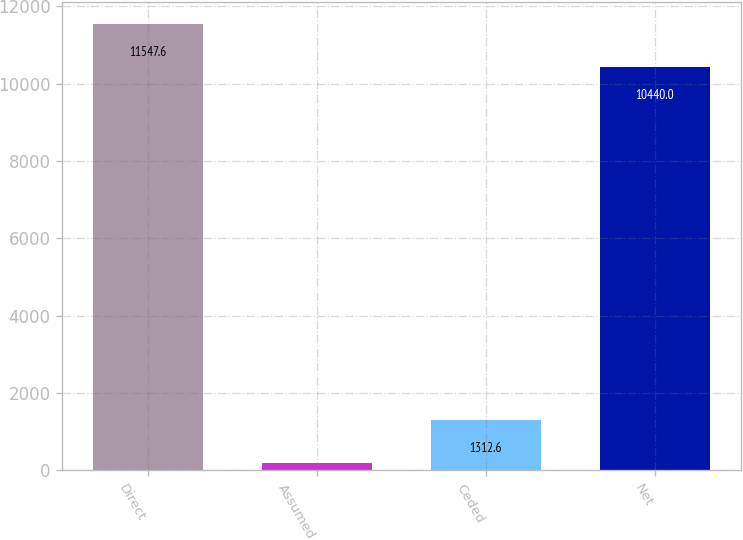Convert chart to OTSL. <chart><loc_0><loc_0><loc_500><loc_500><bar_chart><fcel>Direct<fcel>Assumed<fcel>Ceded<fcel>Net<nl><fcel>11547.6<fcel>205<fcel>1312.6<fcel>10440<nl></chart> 